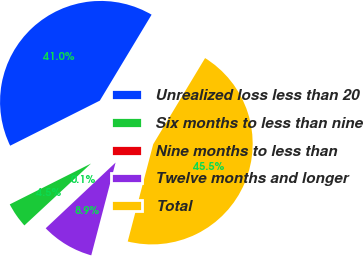<chart> <loc_0><loc_0><loc_500><loc_500><pie_chart><fcel>Unrealized loss less than 20<fcel>Six months to less than nine<fcel>Nine months to less than<fcel>Twelve months and longer<fcel>Total<nl><fcel>41.04%<fcel>4.5%<fcel>0.1%<fcel>8.91%<fcel>45.45%<nl></chart> 